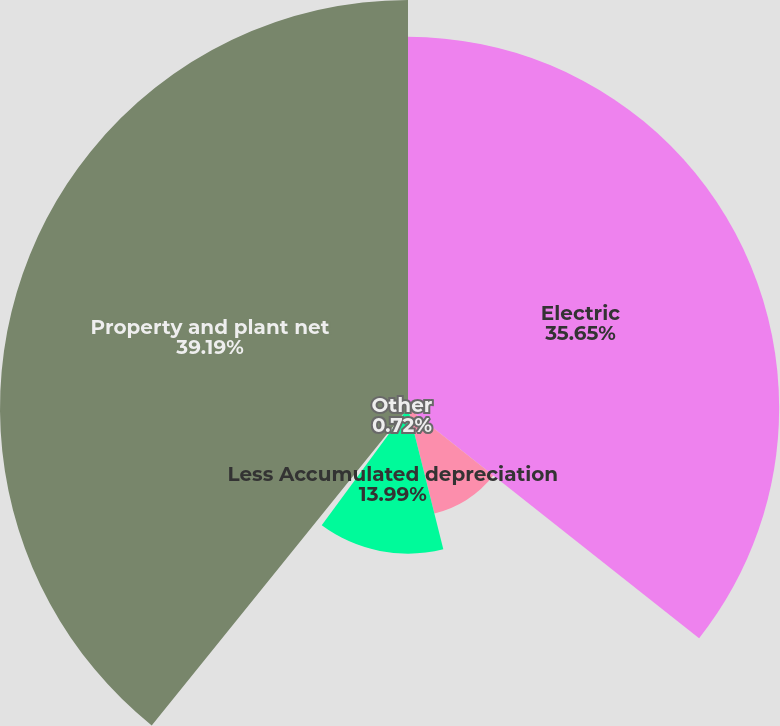Convert chart to OTSL. <chart><loc_0><loc_0><loc_500><loc_500><pie_chart><fcel>Electric<fcel>Natural gas<fcel>Less Accumulated depreciation<fcel>Other<fcel>Property and plant net<nl><fcel>35.65%<fcel>10.45%<fcel>13.99%<fcel>0.72%<fcel>39.19%<nl></chart> 